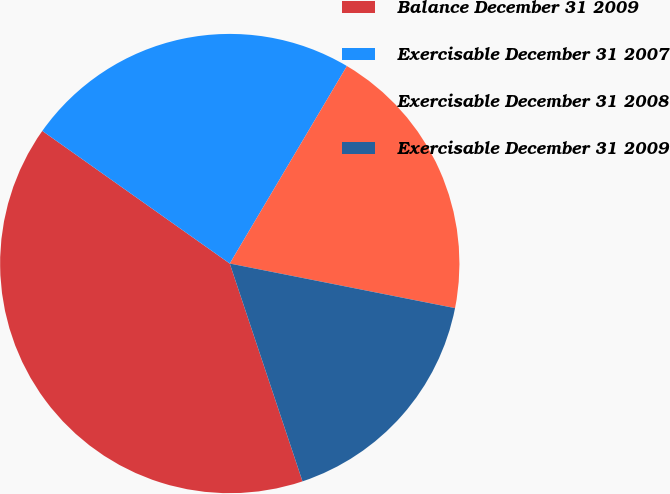Convert chart. <chart><loc_0><loc_0><loc_500><loc_500><pie_chart><fcel>Balance December 31 2009<fcel>Exercisable December 31 2007<fcel>Exercisable December 31 2008<fcel>Exercisable December 31 2009<nl><fcel>39.93%<fcel>23.72%<fcel>19.59%<fcel>16.76%<nl></chart> 